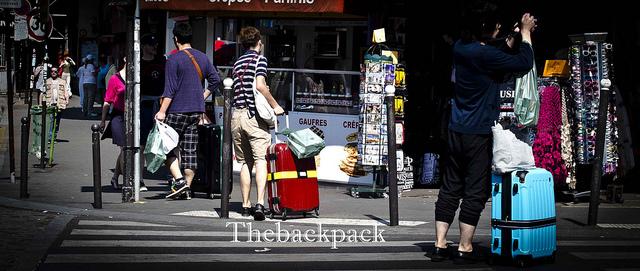Is the image watermarked?
Give a very brief answer. Yes. What color are the suspenders on the person rolling the red suitcase next to them?
Short answer required. Red. Do these people appear to be fighting?
Be succinct. No. 